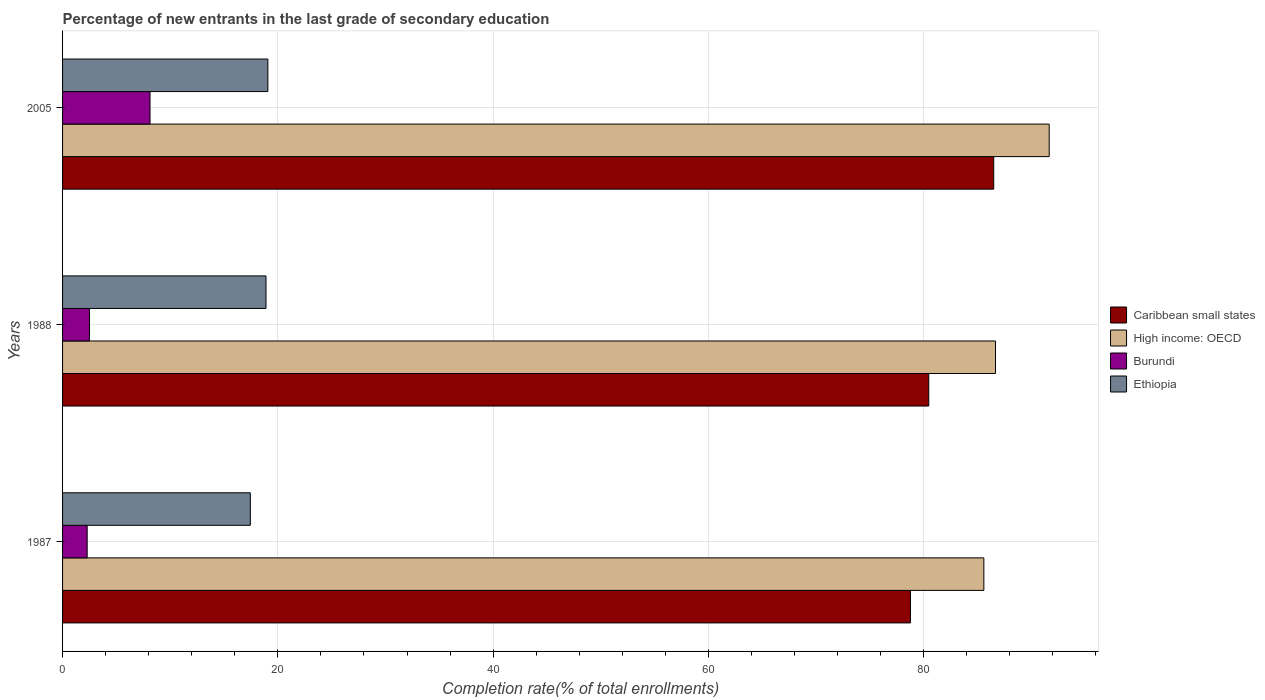How many bars are there on the 2nd tick from the top?
Your answer should be compact. 4. How many bars are there on the 2nd tick from the bottom?
Make the answer very short. 4. What is the label of the 2nd group of bars from the top?
Your answer should be compact. 1988. In how many cases, is the number of bars for a given year not equal to the number of legend labels?
Keep it short and to the point. 0. What is the percentage of new entrants in Burundi in 2005?
Give a very brief answer. 8.12. Across all years, what is the maximum percentage of new entrants in Ethiopia?
Ensure brevity in your answer.  19.07. Across all years, what is the minimum percentage of new entrants in Caribbean small states?
Your answer should be very brief. 78.77. In which year was the percentage of new entrants in Burundi maximum?
Provide a short and direct response. 2005. In which year was the percentage of new entrants in Caribbean small states minimum?
Provide a succinct answer. 1987. What is the total percentage of new entrants in Caribbean small states in the graph?
Offer a terse response. 245.74. What is the difference between the percentage of new entrants in Caribbean small states in 1987 and that in 1988?
Make the answer very short. -1.7. What is the difference between the percentage of new entrants in High income: OECD in 2005 and the percentage of new entrants in Burundi in 1988?
Give a very brief answer. 89.16. What is the average percentage of new entrants in Ethiopia per year?
Provide a short and direct response. 18.47. In the year 1988, what is the difference between the percentage of new entrants in High income: OECD and percentage of new entrants in Ethiopia?
Keep it short and to the point. 67.77. In how many years, is the percentage of new entrants in Ethiopia greater than 64 %?
Make the answer very short. 0. What is the ratio of the percentage of new entrants in Burundi in 1987 to that in 1988?
Provide a succinct answer. 0.91. Is the percentage of new entrants in High income: OECD in 1987 less than that in 1988?
Provide a succinct answer. Yes. What is the difference between the highest and the second highest percentage of new entrants in Burundi?
Give a very brief answer. 5.63. What is the difference between the highest and the lowest percentage of new entrants in Burundi?
Your answer should be compact. 5.84. In how many years, is the percentage of new entrants in Ethiopia greater than the average percentage of new entrants in Ethiopia taken over all years?
Make the answer very short. 2. Is the sum of the percentage of new entrants in High income: OECD in 1987 and 1988 greater than the maximum percentage of new entrants in Ethiopia across all years?
Ensure brevity in your answer.  Yes. Is it the case that in every year, the sum of the percentage of new entrants in High income: OECD and percentage of new entrants in Caribbean small states is greater than the sum of percentage of new entrants in Ethiopia and percentage of new entrants in Burundi?
Your answer should be compact. Yes. What does the 2nd bar from the top in 1988 represents?
Offer a very short reply. Burundi. What does the 1st bar from the bottom in 2005 represents?
Provide a short and direct response. Caribbean small states. How many bars are there?
Your answer should be very brief. 12. How many years are there in the graph?
Your answer should be compact. 3. What is the difference between two consecutive major ticks on the X-axis?
Your response must be concise. 20. Does the graph contain grids?
Your response must be concise. Yes. What is the title of the graph?
Give a very brief answer. Percentage of new entrants in the last grade of secondary education. Does "El Salvador" appear as one of the legend labels in the graph?
Give a very brief answer. No. What is the label or title of the X-axis?
Offer a terse response. Completion rate(% of total enrollments). What is the Completion rate(% of total enrollments) of Caribbean small states in 1987?
Offer a terse response. 78.77. What is the Completion rate(% of total enrollments) of High income: OECD in 1987?
Provide a succinct answer. 85.59. What is the Completion rate(% of total enrollments) in Burundi in 1987?
Offer a terse response. 2.29. What is the Completion rate(% of total enrollments) of Ethiopia in 1987?
Your response must be concise. 17.44. What is the Completion rate(% of total enrollments) of Caribbean small states in 1988?
Give a very brief answer. 80.47. What is the Completion rate(% of total enrollments) of High income: OECD in 1988?
Your response must be concise. 86.67. What is the Completion rate(% of total enrollments) in Burundi in 1988?
Provide a short and direct response. 2.5. What is the Completion rate(% of total enrollments) in Ethiopia in 1988?
Keep it short and to the point. 18.9. What is the Completion rate(% of total enrollments) of Caribbean small states in 2005?
Keep it short and to the point. 86.5. What is the Completion rate(% of total enrollments) in High income: OECD in 2005?
Offer a terse response. 91.66. What is the Completion rate(% of total enrollments) of Burundi in 2005?
Offer a terse response. 8.12. What is the Completion rate(% of total enrollments) in Ethiopia in 2005?
Provide a succinct answer. 19.07. Across all years, what is the maximum Completion rate(% of total enrollments) in Caribbean small states?
Ensure brevity in your answer.  86.5. Across all years, what is the maximum Completion rate(% of total enrollments) of High income: OECD?
Provide a succinct answer. 91.66. Across all years, what is the maximum Completion rate(% of total enrollments) of Burundi?
Your answer should be very brief. 8.12. Across all years, what is the maximum Completion rate(% of total enrollments) of Ethiopia?
Keep it short and to the point. 19.07. Across all years, what is the minimum Completion rate(% of total enrollments) of Caribbean small states?
Provide a succinct answer. 78.77. Across all years, what is the minimum Completion rate(% of total enrollments) in High income: OECD?
Your response must be concise. 85.59. Across all years, what is the minimum Completion rate(% of total enrollments) in Burundi?
Offer a very short reply. 2.29. Across all years, what is the minimum Completion rate(% of total enrollments) of Ethiopia?
Offer a terse response. 17.44. What is the total Completion rate(% of total enrollments) of Caribbean small states in the graph?
Provide a short and direct response. 245.74. What is the total Completion rate(% of total enrollments) in High income: OECD in the graph?
Offer a very short reply. 263.92. What is the total Completion rate(% of total enrollments) in Burundi in the graph?
Provide a succinct answer. 12.91. What is the total Completion rate(% of total enrollments) of Ethiopia in the graph?
Ensure brevity in your answer.  55.42. What is the difference between the Completion rate(% of total enrollments) of Caribbean small states in 1987 and that in 1988?
Ensure brevity in your answer.  -1.7. What is the difference between the Completion rate(% of total enrollments) in High income: OECD in 1987 and that in 1988?
Your answer should be compact. -1.08. What is the difference between the Completion rate(% of total enrollments) of Burundi in 1987 and that in 1988?
Your answer should be compact. -0.21. What is the difference between the Completion rate(% of total enrollments) in Ethiopia in 1987 and that in 1988?
Your answer should be very brief. -1.46. What is the difference between the Completion rate(% of total enrollments) in Caribbean small states in 1987 and that in 2005?
Provide a short and direct response. -7.74. What is the difference between the Completion rate(% of total enrollments) in High income: OECD in 1987 and that in 2005?
Your response must be concise. -6.07. What is the difference between the Completion rate(% of total enrollments) of Burundi in 1987 and that in 2005?
Make the answer very short. -5.84. What is the difference between the Completion rate(% of total enrollments) in Ethiopia in 1987 and that in 2005?
Your response must be concise. -1.63. What is the difference between the Completion rate(% of total enrollments) in Caribbean small states in 1988 and that in 2005?
Your response must be concise. -6.03. What is the difference between the Completion rate(% of total enrollments) in High income: OECD in 1988 and that in 2005?
Make the answer very short. -4.99. What is the difference between the Completion rate(% of total enrollments) in Burundi in 1988 and that in 2005?
Your response must be concise. -5.63. What is the difference between the Completion rate(% of total enrollments) of Ethiopia in 1988 and that in 2005?
Provide a short and direct response. -0.17. What is the difference between the Completion rate(% of total enrollments) of Caribbean small states in 1987 and the Completion rate(% of total enrollments) of High income: OECD in 1988?
Your response must be concise. -7.91. What is the difference between the Completion rate(% of total enrollments) of Caribbean small states in 1987 and the Completion rate(% of total enrollments) of Burundi in 1988?
Your answer should be very brief. 76.27. What is the difference between the Completion rate(% of total enrollments) of Caribbean small states in 1987 and the Completion rate(% of total enrollments) of Ethiopia in 1988?
Ensure brevity in your answer.  59.87. What is the difference between the Completion rate(% of total enrollments) of High income: OECD in 1987 and the Completion rate(% of total enrollments) of Burundi in 1988?
Provide a short and direct response. 83.09. What is the difference between the Completion rate(% of total enrollments) in High income: OECD in 1987 and the Completion rate(% of total enrollments) in Ethiopia in 1988?
Make the answer very short. 66.69. What is the difference between the Completion rate(% of total enrollments) in Burundi in 1987 and the Completion rate(% of total enrollments) in Ethiopia in 1988?
Provide a succinct answer. -16.61. What is the difference between the Completion rate(% of total enrollments) of Caribbean small states in 1987 and the Completion rate(% of total enrollments) of High income: OECD in 2005?
Provide a short and direct response. -12.89. What is the difference between the Completion rate(% of total enrollments) in Caribbean small states in 1987 and the Completion rate(% of total enrollments) in Burundi in 2005?
Give a very brief answer. 70.64. What is the difference between the Completion rate(% of total enrollments) of Caribbean small states in 1987 and the Completion rate(% of total enrollments) of Ethiopia in 2005?
Provide a succinct answer. 59.69. What is the difference between the Completion rate(% of total enrollments) in High income: OECD in 1987 and the Completion rate(% of total enrollments) in Burundi in 2005?
Ensure brevity in your answer.  77.46. What is the difference between the Completion rate(% of total enrollments) of High income: OECD in 1987 and the Completion rate(% of total enrollments) of Ethiopia in 2005?
Make the answer very short. 66.52. What is the difference between the Completion rate(% of total enrollments) in Burundi in 1987 and the Completion rate(% of total enrollments) in Ethiopia in 2005?
Give a very brief answer. -16.79. What is the difference between the Completion rate(% of total enrollments) of Caribbean small states in 1988 and the Completion rate(% of total enrollments) of High income: OECD in 2005?
Give a very brief answer. -11.19. What is the difference between the Completion rate(% of total enrollments) of Caribbean small states in 1988 and the Completion rate(% of total enrollments) of Burundi in 2005?
Provide a short and direct response. 72.35. What is the difference between the Completion rate(% of total enrollments) in Caribbean small states in 1988 and the Completion rate(% of total enrollments) in Ethiopia in 2005?
Your response must be concise. 61.4. What is the difference between the Completion rate(% of total enrollments) in High income: OECD in 1988 and the Completion rate(% of total enrollments) in Burundi in 2005?
Provide a succinct answer. 78.55. What is the difference between the Completion rate(% of total enrollments) in High income: OECD in 1988 and the Completion rate(% of total enrollments) in Ethiopia in 2005?
Offer a terse response. 67.6. What is the difference between the Completion rate(% of total enrollments) in Burundi in 1988 and the Completion rate(% of total enrollments) in Ethiopia in 2005?
Make the answer very short. -16.57. What is the average Completion rate(% of total enrollments) of Caribbean small states per year?
Your response must be concise. 81.91. What is the average Completion rate(% of total enrollments) of High income: OECD per year?
Your answer should be very brief. 87.97. What is the average Completion rate(% of total enrollments) in Burundi per year?
Offer a very short reply. 4.3. What is the average Completion rate(% of total enrollments) of Ethiopia per year?
Provide a succinct answer. 18.47. In the year 1987, what is the difference between the Completion rate(% of total enrollments) of Caribbean small states and Completion rate(% of total enrollments) of High income: OECD?
Give a very brief answer. -6.82. In the year 1987, what is the difference between the Completion rate(% of total enrollments) of Caribbean small states and Completion rate(% of total enrollments) of Burundi?
Make the answer very short. 76.48. In the year 1987, what is the difference between the Completion rate(% of total enrollments) of Caribbean small states and Completion rate(% of total enrollments) of Ethiopia?
Give a very brief answer. 61.32. In the year 1987, what is the difference between the Completion rate(% of total enrollments) in High income: OECD and Completion rate(% of total enrollments) in Burundi?
Provide a succinct answer. 83.3. In the year 1987, what is the difference between the Completion rate(% of total enrollments) in High income: OECD and Completion rate(% of total enrollments) in Ethiopia?
Offer a terse response. 68.15. In the year 1987, what is the difference between the Completion rate(% of total enrollments) of Burundi and Completion rate(% of total enrollments) of Ethiopia?
Your answer should be compact. -15.16. In the year 1988, what is the difference between the Completion rate(% of total enrollments) of Caribbean small states and Completion rate(% of total enrollments) of High income: OECD?
Offer a very short reply. -6.2. In the year 1988, what is the difference between the Completion rate(% of total enrollments) of Caribbean small states and Completion rate(% of total enrollments) of Burundi?
Your response must be concise. 77.97. In the year 1988, what is the difference between the Completion rate(% of total enrollments) of Caribbean small states and Completion rate(% of total enrollments) of Ethiopia?
Provide a succinct answer. 61.57. In the year 1988, what is the difference between the Completion rate(% of total enrollments) in High income: OECD and Completion rate(% of total enrollments) in Burundi?
Your response must be concise. 84.17. In the year 1988, what is the difference between the Completion rate(% of total enrollments) of High income: OECD and Completion rate(% of total enrollments) of Ethiopia?
Keep it short and to the point. 67.77. In the year 1988, what is the difference between the Completion rate(% of total enrollments) in Burundi and Completion rate(% of total enrollments) in Ethiopia?
Your answer should be very brief. -16.4. In the year 2005, what is the difference between the Completion rate(% of total enrollments) of Caribbean small states and Completion rate(% of total enrollments) of High income: OECD?
Offer a very short reply. -5.16. In the year 2005, what is the difference between the Completion rate(% of total enrollments) of Caribbean small states and Completion rate(% of total enrollments) of Burundi?
Offer a terse response. 78.38. In the year 2005, what is the difference between the Completion rate(% of total enrollments) in Caribbean small states and Completion rate(% of total enrollments) in Ethiopia?
Your response must be concise. 67.43. In the year 2005, what is the difference between the Completion rate(% of total enrollments) in High income: OECD and Completion rate(% of total enrollments) in Burundi?
Keep it short and to the point. 83.54. In the year 2005, what is the difference between the Completion rate(% of total enrollments) in High income: OECD and Completion rate(% of total enrollments) in Ethiopia?
Provide a short and direct response. 72.59. In the year 2005, what is the difference between the Completion rate(% of total enrollments) of Burundi and Completion rate(% of total enrollments) of Ethiopia?
Keep it short and to the point. -10.95. What is the ratio of the Completion rate(% of total enrollments) of Caribbean small states in 1987 to that in 1988?
Provide a short and direct response. 0.98. What is the ratio of the Completion rate(% of total enrollments) in High income: OECD in 1987 to that in 1988?
Give a very brief answer. 0.99. What is the ratio of the Completion rate(% of total enrollments) in Burundi in 1987 to that in 1988?
Make the answer very short. 0.92. What is the ratio of the Completion rate(% of total enrollments) of Ethiopia in 1987 to that in 1988?
Ensure brevity in your answer.  0.92. What is the ratio of the Completion rate(% of total enrollments) of Caribbean small states in 1987 to that in 2005?
Give a very brief answer. 0.91. What is the ratio of the Completion rate(% of total enrollments) in High income: OECD in 1987 to that in 2005?
Your response must be concise. 0.93. What is the ratio of the Completion rate(% of total enrollments) in Burundi in 1987 to that in 2005?
Your response must be concise. 0.28. What is the ratio of the Completion rate(% of total enrollments) in Ethiopia in 1987 to that in 2005?
Your answer should be compact. 0.91. What is the ratio of the Completion rate(% of total enrollments) in Caribbean small states in 1988 to that in 2005?
Give a very brief answer. 0.93. What is the ratio of the Completion rate(% of total enrollments) in High income: OECD in 1988 to that in 2005?
Ensure brevity in your answer.  0.95. What is the ratio of the Completion rate(% of total enrollments) of Burundi in 1988 to that in 2005?
Offer a very short reply. 0.31. What is the ratio of the Completion rate(% of total enrollments) of Ethiopia in 1988 to that in 2005?
Your response must be concise. 0.99. What is the difference between the highest and the second highest Completion rate(% of total enrollments) in Caribbean small states?
Provide a succinct answer. 6.03. What is the difference between the highest and the second highest Completion rate(% of total enrollments) of High income: OECD?
Provide a short and direct response. 4.99. What is the difference between the highest and the second highest Completion rate(% of total enrollments) of Burundi?
Your answer should be very brief. 5.63. What is the difference between the highest and the second highest Completion rate(% of total enrollments) in Ethiopia?
Your response must be concise. 0.17. What is the difference between the highest and the lowest Completion rate(% of total enrollments) of Caribbean small states?
Your answer should be very brief. 7.74. What is the difference between the highest and the lowest Completion rate(% of total enrollments) of High income: OECD?
Keep it short and to the point. 6.07. What is the difference between the highest and the lowest Completion rate(% of total enrollments) in Burundi?
Provide a short and direct response. 5.84. What is the difference between the highest and the lowest Completion rate(% of total enrollments) in Ethiopia?
Give a very brief answer. 1.63. 